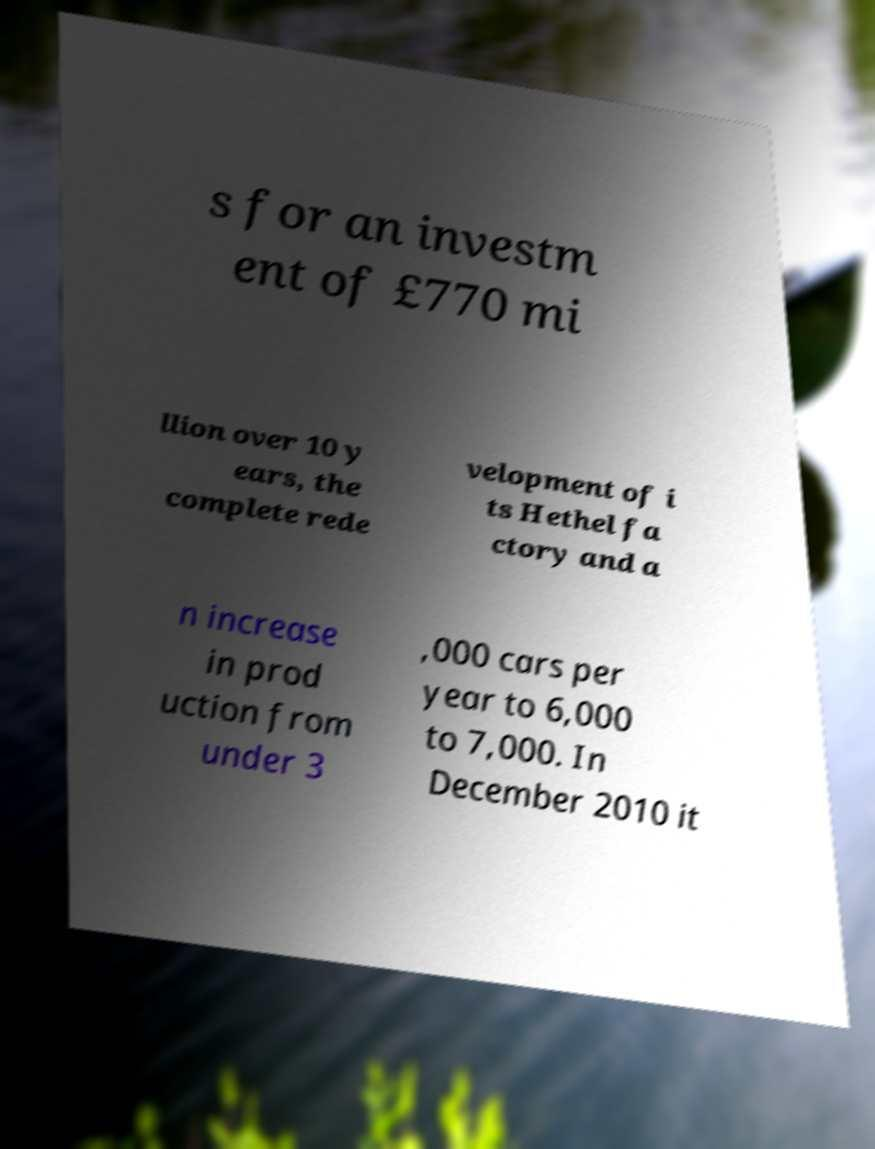Could you assist in decoding the text presented in this image and type it out clearly? s for an investm ent of £770 mi llion over 10 y ears, the complete rede velopment of i ts Hethel fa ctory and a n increase in prod uction from under 3 ,000 cars per year to 6,000 to 7,000. In December 2010 it 